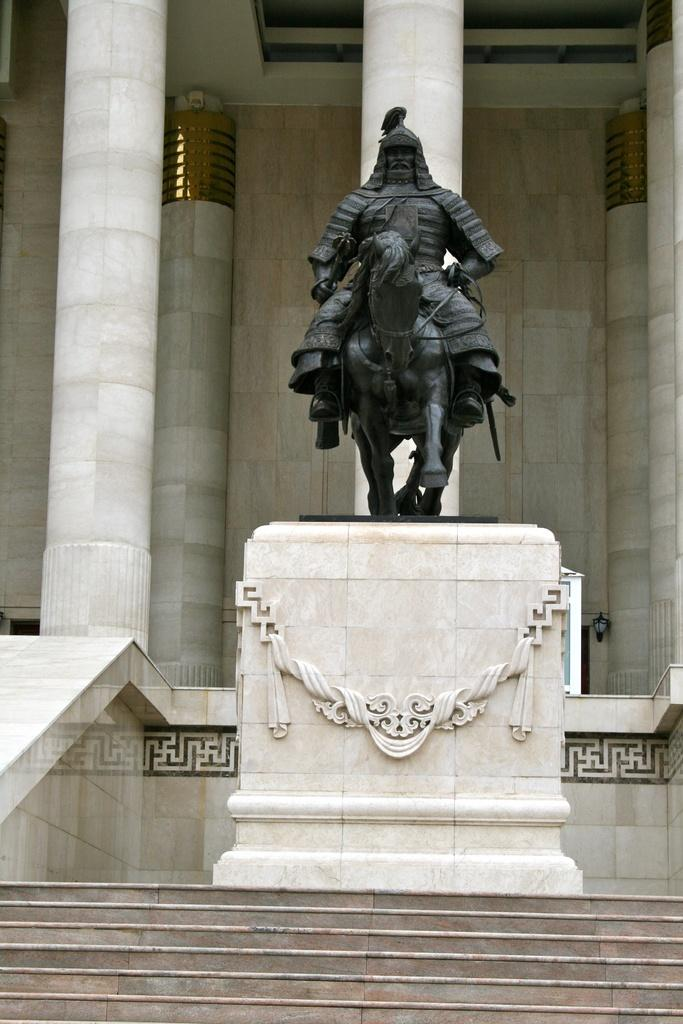What is the main subject of the image? The main subject of the image is a statue of a person sitting on a horse. Where is the statue located in relation to the building? The statue is in front of pillars of a building. What architectural feature is visible at the bottom of the image? There are stairs at the bottom of the image. What type of steel is used to construct the ant in the image? There is no ant present in the image, and therefore no steel construction can be observed. 